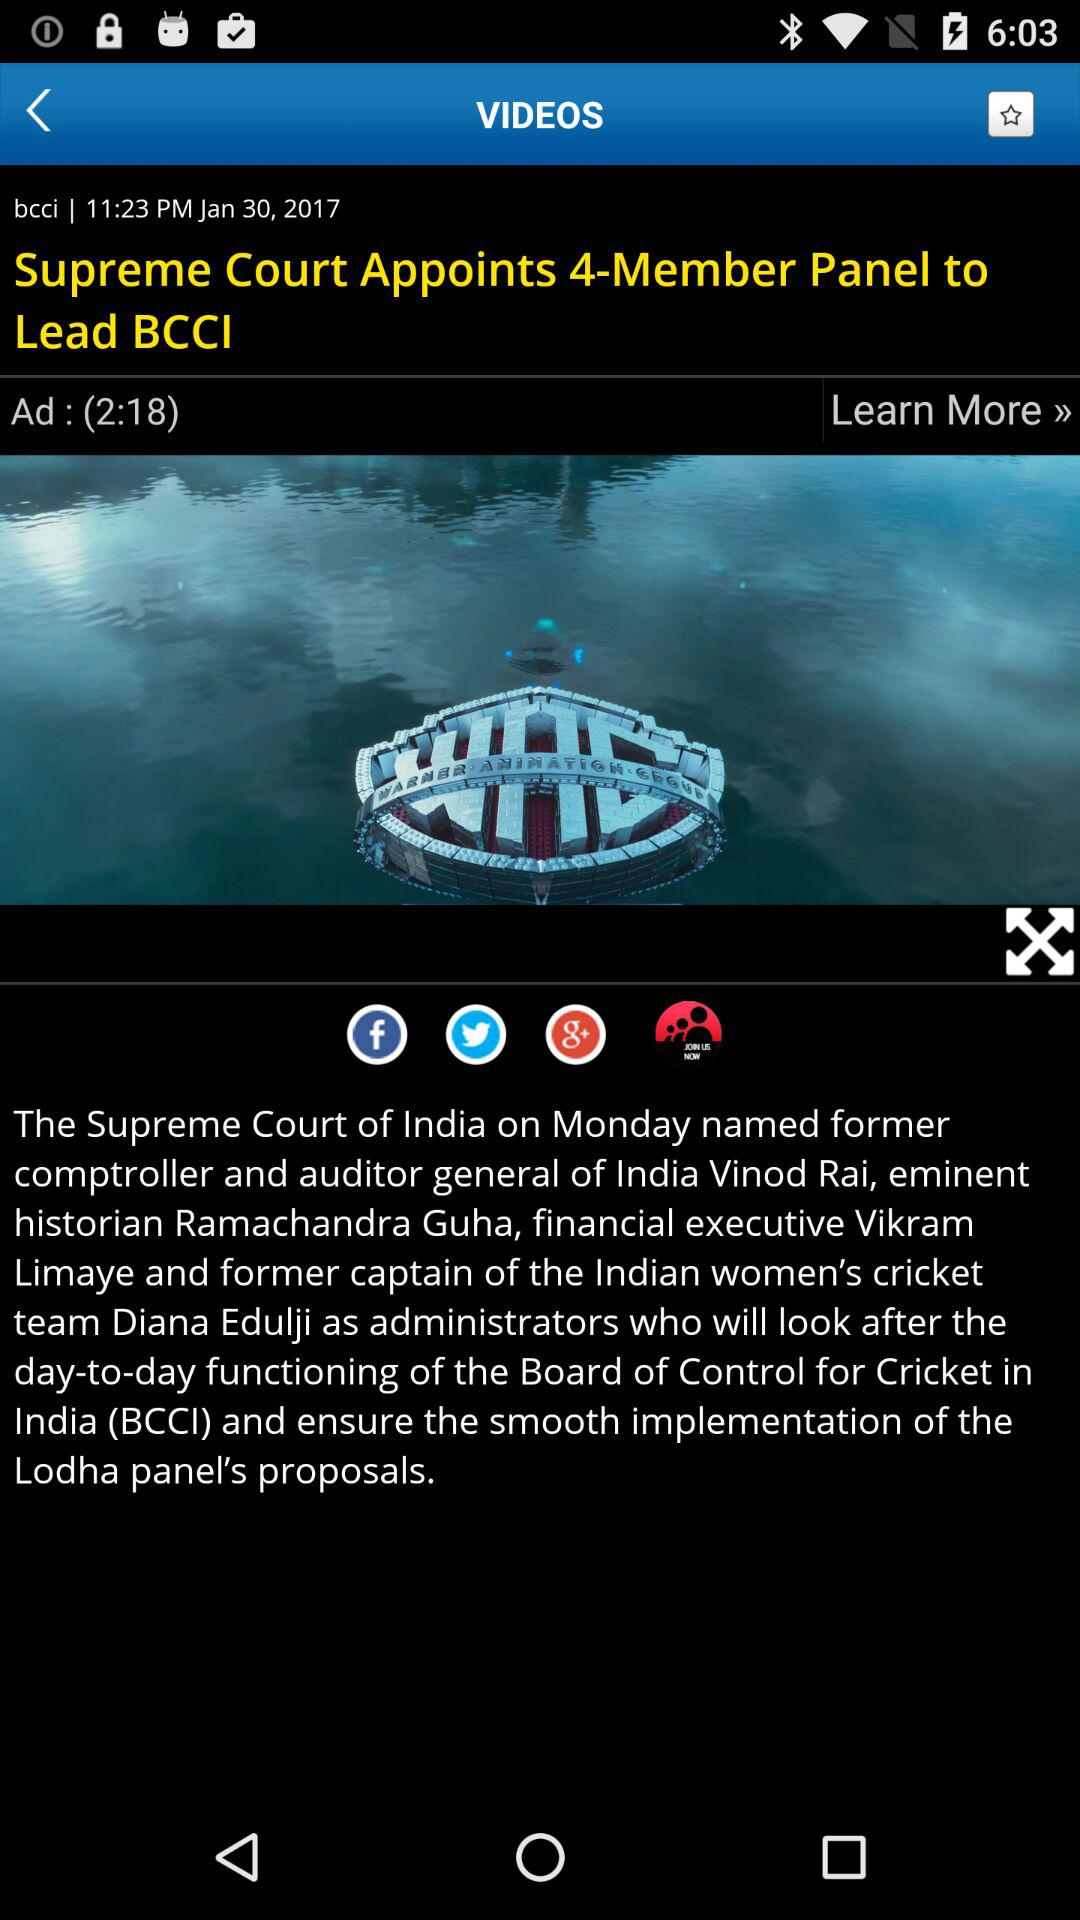At what time was the article posted? The article was posted at 11:23 PM. 